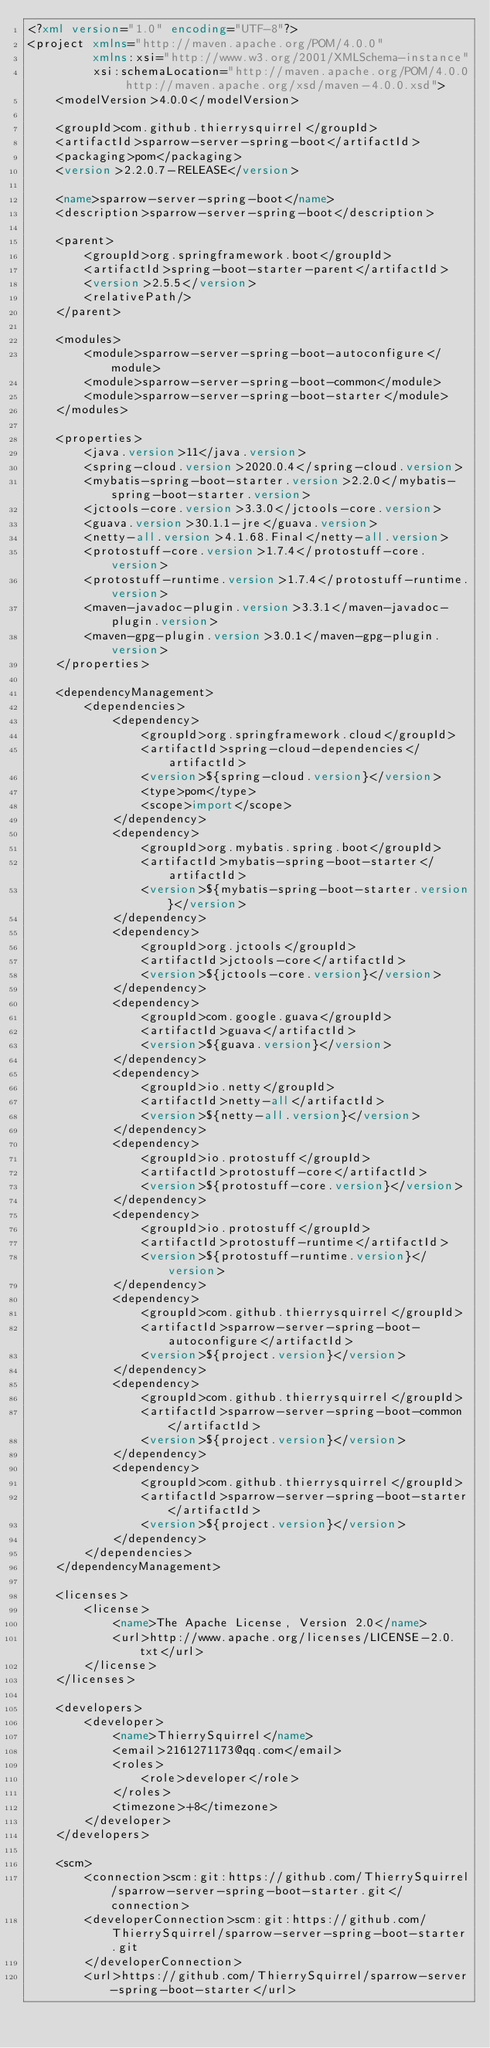<code> <loc_0><loc_0><loc_500><loc_500><_XML_><?xml version="1.0" encoding="UTF-8"?>
<project xmlns="http://maven.apache.org/POM/4.0.0"
         xmlns:xsi="http://www.w3.org/2001/XMLSchema-instance"
         xsi:schemaLocation="http://maven.apache.org/POM/4.0.0 http://maven.apache.org/xsd/maven-4.0.0.xsd">
    <modelVersion>4.0.0</modelVersion>

    <groupId>com.github.thierrysquirrel</groupId>
    <artifactId>sparrow-server-spring-boot</artifactId>
    <packaging>pom</packaging>
    <version>2.2.0.7-RELEASE</version>

    <name>sparrow-server-spring-boot</name>
    <description>sparrow-server-spring-boot</description>

    <parent>
        <groupId>org.springframework.boot</groupId>
        <artifactId>spring-boot-starter-parent</artifactId>
        <version>2.5.5</version>
        <relativePath/>
    </parent>

    <modules>
        <module>sparrow-server-spring-boot-autoconfigure</module>
        <module>sparrow-server-spring-boot-common</module>
        <module>sparrow-server-spring-boot-starter</module>
    </modules>

    <properties>
        <java.version>11</java.version>
        <spring-cloud.version>2020.0.4</spring-cloud.version>
        <mybatis-spring-boot-starter.version>2.2.0</mybatis-spring-boot-starter.version>
        <jctools-core.version>3.3.0</jctools-core.version>
        <guava.version>30.1.1-jre</guava.version>
        <netty-all.version>4.1.68.Final</netty-all.version>
        <protostuff-core.version>1.7.4</protostuff-core.version>
        <protostuff-runtime.version>1.7.4</protostuff-runtime.version>
        <maven-javadoc-plugin.version>3.3.1</maven-javadoc-plugin.version>
        <maven-gpg-plugin.version>3.0.1</maven-gpg-plugin.version>
    </properties>

    <dependencyManagement>
        <dependencies>
            <dependency>
                <groupId>org.springframework.cloud</groupId>
                <artifactId>spring-cloud-dependencies</artifactId>
                <version>${spring-cloud.version}</version>
                <type>pom</type>
                <scope>import</scope>
            </dependency>
            <dependency>
                <groupId>org.mybatis.spring.boot</groupId>
                <artifactId>mybatis-spring-boot-starter</artifactId>
                <version>${mybatis-spring-boot-starter.version}</version>
            </dependency>
            <dependency>
                <groupId>org.jctools</groupId>
                <artifactId>jctools-core</artifactId>
                <version>${jctools-core.version}</version>
            </dependency>
            <dependency>
                <groupId>com.google.guava</groupId>
                <artifactId>guava</artifactId>
                <version>${guava.version}</version>
            </dependency>
            <dependency>
                <groupId>io.netty</groupId>
                <artifactId>netty-all</artifactId>
                <version>${netty-all.version}</version>
            </dependency>
            <dependency>
                <groupId>io.protostuff</groupId>
                <artifactId>protostuff-core</artifactId>
                <version>${protostuff-core.version}</version>
            </dependency>
            <dependency>
                <groupId>io.protostuff</groupId>
                <artifactId>protostuff-runtime</artifactId>
                <version>${protostuff-runtime.version}</version>
            </dependency>
            <dependency>
                <groupId>com.github.thierrysquirrel</groupId>
                <artifactId>sparrow-server-spring-boot-autoconfigure</artifactId>
                <version>${project.version}</version>
            </dependency>
            <dependency>
                <groupId>com.github.thierrysquirrel</groupId>
                <artifactId>sparrow-server-spring-boot-common</artifactId>
                <version>${project.version}</version>
            </dependency>
            <dependency>
                <groupId>com.github.thierrysquirrel</groupId>
                <artifactId>sparrow-server-spring-boot-starter</artifactId>
                <version>${project.version}</version>
            </dependency>
        </dependencies>
    </dependencyManagement>

    <licenses>
        <license>
            <name>The Apache License, Version 2.0</name>
            <url>http://www.apache.org/licenses/LICENSE-2.0.txt</url>
        </license>
    </licenses>

    <developers>
        <developer>
            <name>ThierrySquirrel</name>
            <email>2161271173@qq.com</email>
            <roles>
                <role>developer</role>
            </roles>
            <timezone>+8</timezone>
        </developer>
    </developers>

    <scm>
        <connection>scm:git:https://github.com/ThierrySquirrel/sparrow-server-spring-boot-starter.git</connection>
        <developerConnection>scm:git:https://github.com/ThierrySquirrel/sparrow-server-spring-boot-starter.git
        </developerConnection>
        <url>https://github.com/ThierrySquirrel/sparrow-server-spring-boot-starter</url></code> 